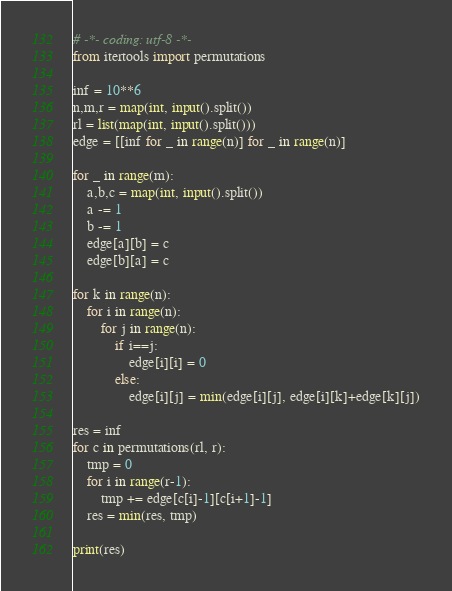<code> <loc_0><loc_0><loc_500><loc_500><_Python_># -*- coding: utf-8 -*-
from itertools import permutations

inf = 10**6
n,m,r = map(int, input().split())
rl = list(map(int, input().split()))
edge = [[inf for _ in range(n)] for _ in range(n)]

for _ in range(m):
    a,b,c = map(int, input().split())
    a -= 1
    b -= 1
    edge[a][b] = c
    edge[b][a] = c

for k in range(n):
    for i in range(n):
        for j in range(n):
            if i==j:
                edge[i][i] = 0
            else:
                edge[i][j] = min(edge[i][j], edge[i][k]+edge[k][j])

res = inf
for c in permutations(rl, r):
    tmp = 0
    for i in range(r-1):
        tmp += edge[c[i]-1][c[i+1]-1]
    res = min(res, tmp)

print(res)
</code> 